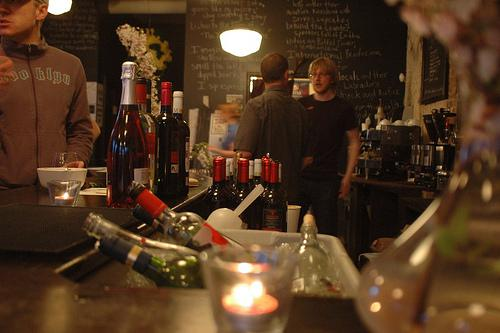Question: where was the picture taken?
Choices:
A. At a bar.
B. In a restaurant.
C. In a cafe.
D. In a store.
Answer with the letter. Answer: A Question: who is wearing glasses?
Choices:
A. The woman in the middle.
B. The child.
C. The police officer.
D. The man on the right.
Answer with the letter. Answer: D 